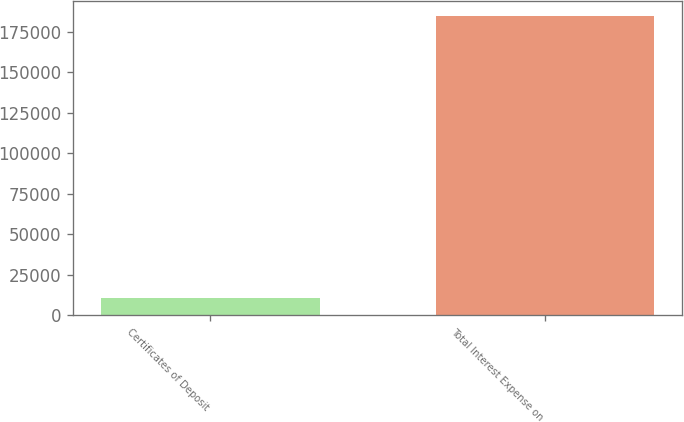Convert chart to OTSL. <chart><loc_0><loc_0><loc_500><loc_500><bar_chart><fcel>Certificates of Deposit<fcel>Total Interest Expense on<nl><fcel>10780<fcel>185032<nl></chart> 